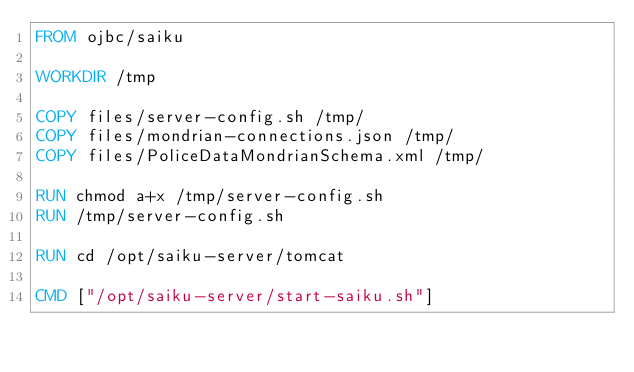Convert code to text. <code><loc_0><loc_0><loc_500><loc_500><_Dockerfile_>FROM ojbc/saiku

WORKDIR /tmp

COPY files/server-config.sh /tmp/
COPY files/mondrian-connections.json /tmp/
COPY files/PoliceDataMondrianSchema.xml /tmp/

RUN chmod a+x /tmp/server-config.sh
RUN /tmp/server-config.sh

RUN cd /opt/saiku-server/tomcat

CMD ["/opt/saiku-server/start-saiku.sh"]</code> 